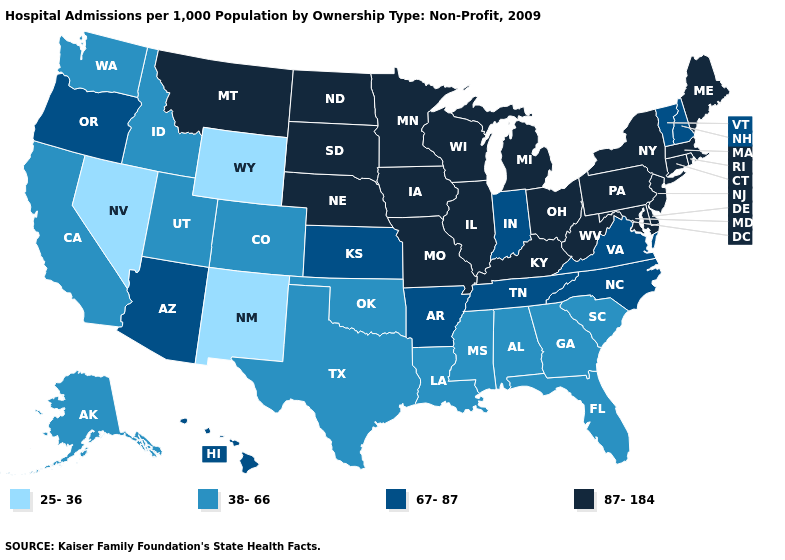Which states hav the highest value in the Northeast?
Write a very short answer. Connecticut, Maine, Massachusetts, New Jersey, New York, Pennsylvania, Rhode Island. Name the states that have a value in the range 25-36?
Quick response, please. Nevada, New Mexico, Wyoming. What is the highest value in the West ?
Be succinct. 87-184. Does West Virginia have the lowest value in the USA?
Be succinct. No. What is the value of North Dakota?
Write a very short answer. 87-184. Which states have the lowest value in the USA?
Answer briefly. Nevada, New Mexico, Wyoming. What is the value of Oklahoma?
Write a very short answer. 38-66. What is the value of Mississippi?
Give a very brief answer. 38-66. What is the value of Iowa?
Give a very brief answer. 87-184. Among the states that border Wyoming , does Montana have the lowest value?
Quick response, please. No. Is the legend a continuous bar?
Quick response, please. No. Among the states that border Alabama , which have the lowest value?
Be succinct. Florida, Georgia, Mississippi. What is the highest value in the USA?
Write a very short answer. 87-184. What is the lowest value in the South?
Concise answer only. 38-66. 